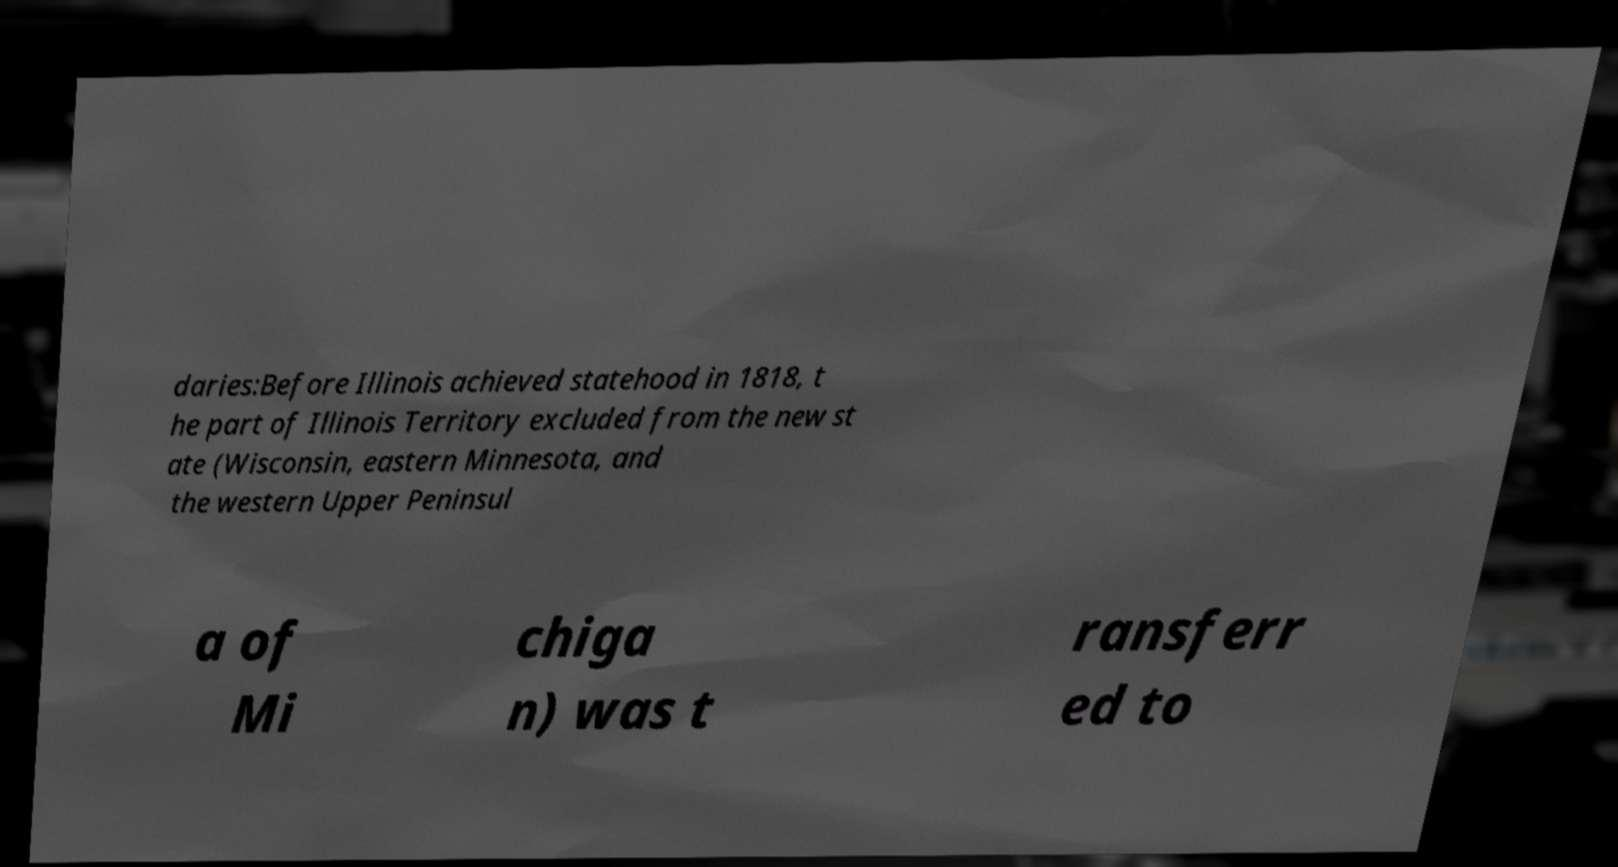I need the written content from this picture converted into text. Can you do that? daries:Before Illinois achieved statehood in 1818, t he part of Illinois Territory excluded from the new st ate (Wisconsin, eastern Minnesota, and the western Upper Peninsul a of Mi chiga n) was t ransferr ed to 